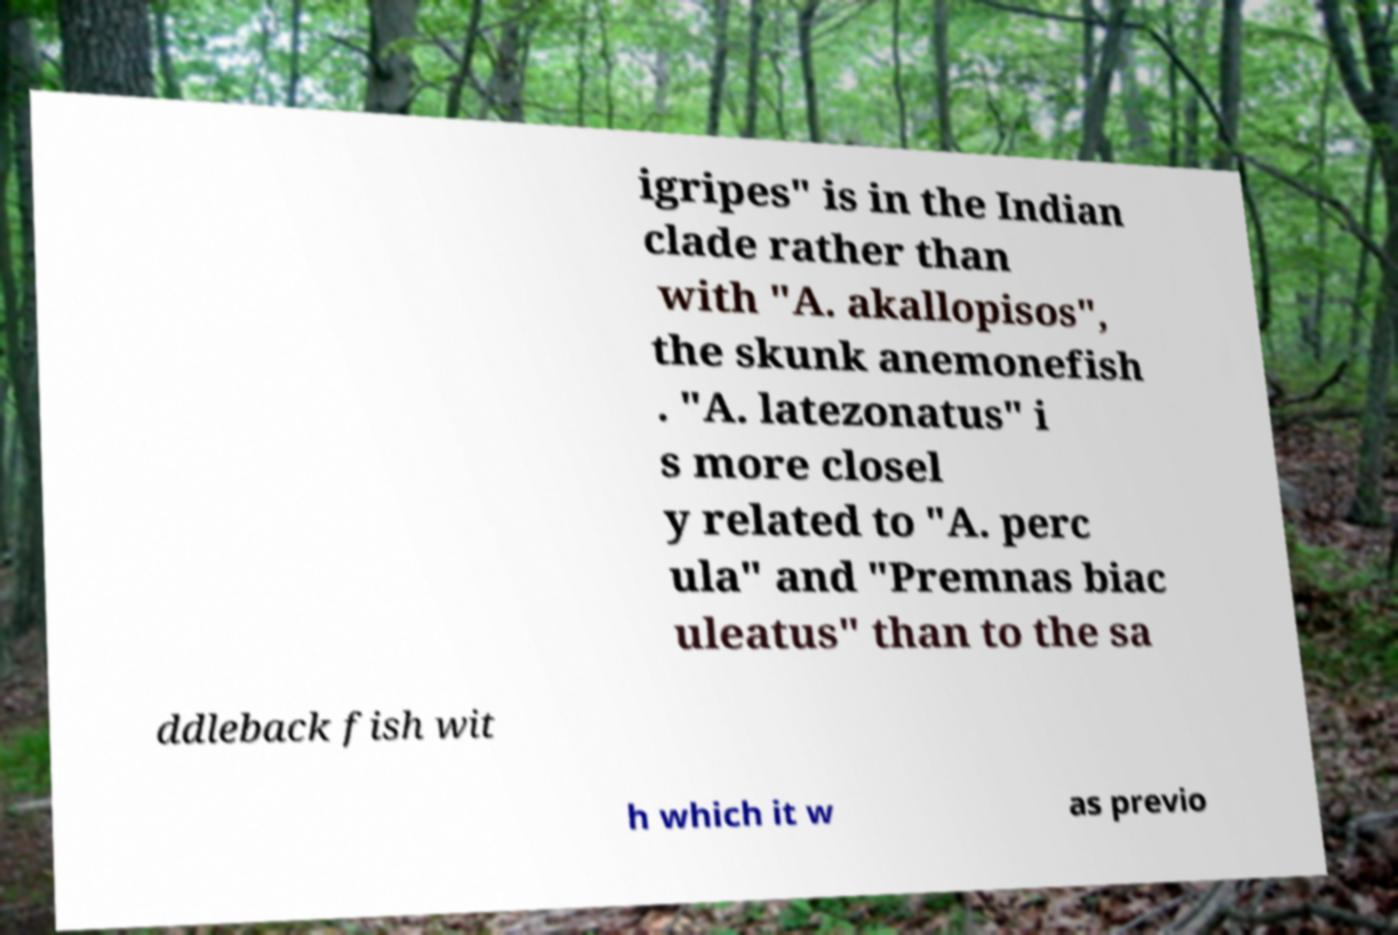There's text embedded in this image that I need extracted. Can you transcribe it verbatim? igripes" is in the Indian clade rather than with "A. akallopisos", the skunk anemonefish . "A. latezonatus" i s more closel y related to "A. perc ula" and "Premnas biac uleatus" than to the sa ddleback fish wit h which it w as previo 